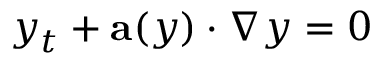<formula> <loc_0><loc_0><loc_500><loc_500>y _ { t } + a ( y ) \cdot \nabla y = 0</formula> 